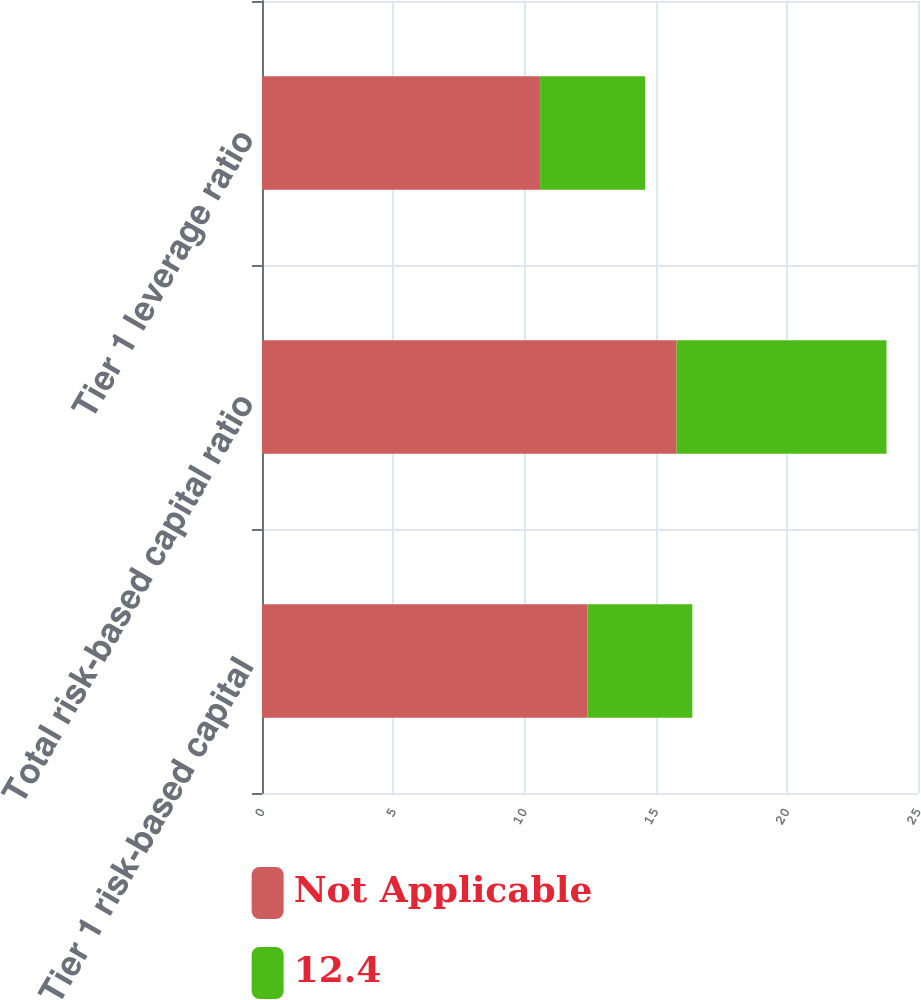Convert chart. <chart><loc_0><loc_0><loc_500><loc_500><stacked_bar_chart><ecel><fcel>Tier 1 risk-based capital<fcel>Total risk-based capital ratio<fcel>Tier 1 leverage ratio<nl><fcel>Not Applicable<fcel>12.4<fcel>15.8<fcel>10.6<nl><fcel>12.4<fcel>4<fcel>8<fcel>4<nl></chart> 